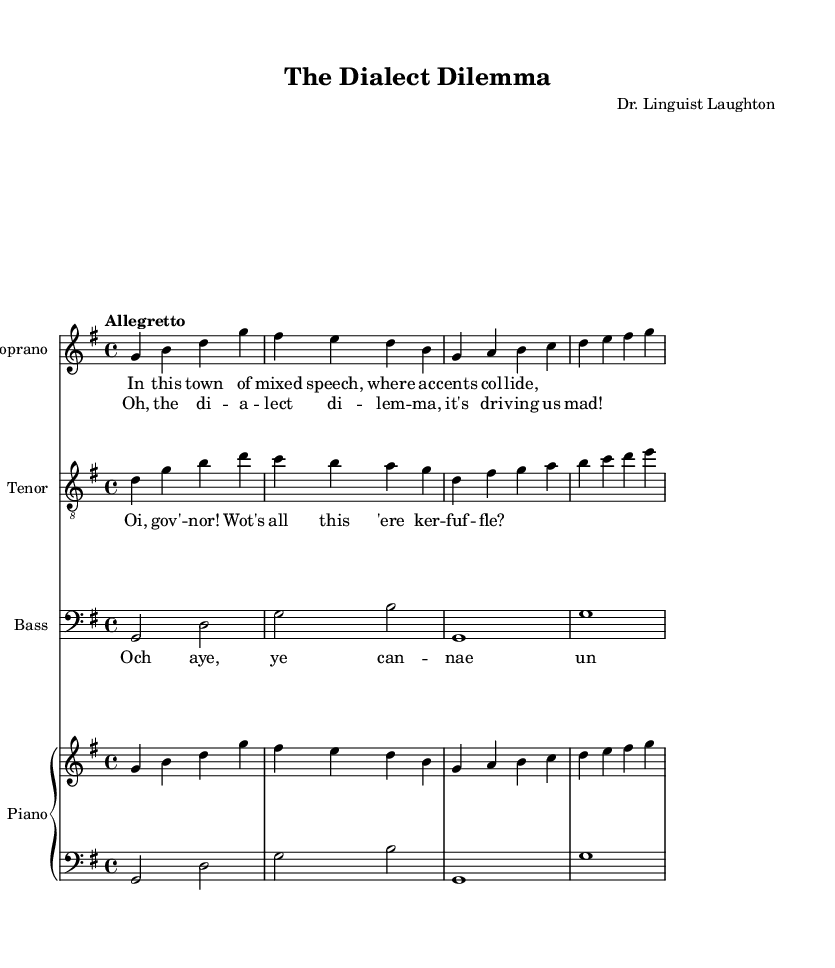What is the key signature of this music? The key signature for the piece is G major, which has one sharp (F#). This can be identified at the beginning of the staff where the sharps are indicated.
Answer: G major What is the time signature of this music? The time signature is 4/4, which means there are four beats per measure and the quarter note gets one beat. This is indicated at the beginning of the score with the 4/4 notation.
Answer: 4/4 What is the tempo marking for this music? The tempo marking is "Allegretto." This is noted at the start of the score, giving a general idea of the speed at which the piece should be played.
Answer: Allegretto Which voice has the lyric "Och aye, ye can -- nae un -- der -- stand a word they say!"? This lyric is sung by the bass voice, as indicated by the staff labeled "Bass" and the corresponding lyrics underneath the bass line.
Answer: Bass How many staves are used for the singers? There are three staves used for the singers: one for soprano, one for tenor, and one for bass. Each staff is labeled accordingly and contains the music for each voice.
Answer: Three What humorous effect is portrayed by the different dialects used in the lyrics? The different dialects create a comedic contrast and confusion among the characters, enhancing the humor. For example, the tenor uses Cockney slang, while the bass has a Scottish dialect. The interaction between these dialects adds to the charm and humor of the opera.
Answer: Comedic contrast 